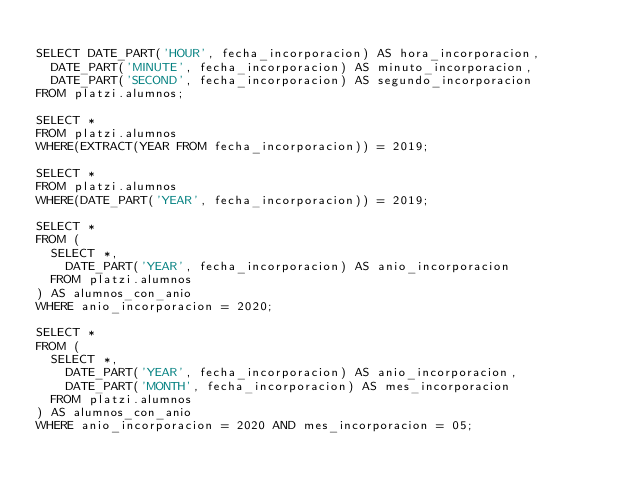Convert code to text. <code><loc_0><loc_0><loc_500><loc_500><_SQL_>
SELECT DATE_PART('HOUR', fecha_incorporacion) AS hora_incorporacion,
	DATE_PART('MINUTE', fecha_incorporacion) AS minuto_incorporacion,
	DATE_PART('SECOND', fecha_incorporacion) AS segundo_incorporacion
FROM platzi.alumnos;

SELECT *
FROM platzi.alumnos
WHERE(EXTRACT(YEAR FROM fecha_incorporacion)) = 2019;

SELECT *
FROM platzi.alumnos
WHERE(DATE_PART('YEAR', fecha_incorporacion)) = 2019;

SELECT *
FROM (
	SELECT *,
		DATE_PART('YEAR', fecha_incorporacion) AS anio_incorporacion
	FROM platzi.alumnos
) AS alumnos_con_anio
WHERE anio_incorporacion = 2020;

SELECT *
FROM (
	SELECT *,
		DATE_PART('YEAR', fecha_incorporacion) AS anio_incorporacion,
		DATE_PART('MONTH', fecha_incorporacion) AS mes_incorporacion
	FROM platzi.alumnos
) AS alumnos_con_anio
WHERE anio_incorporacion = 2020 AND mes_incorporacion = 05;</code> 